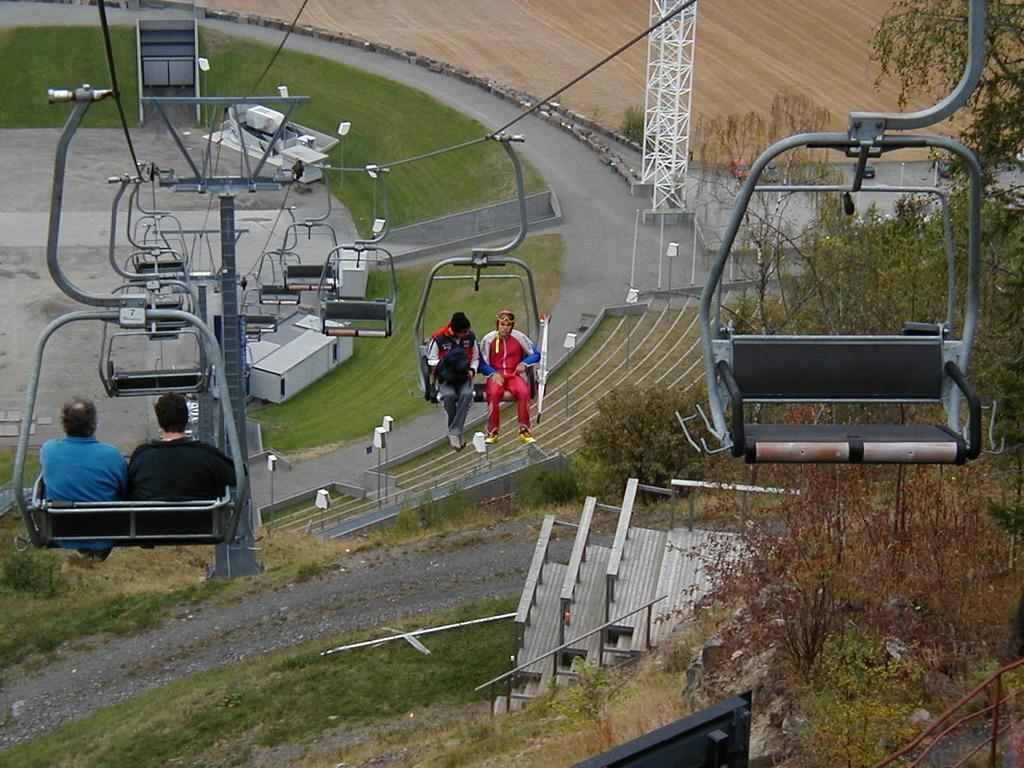What mode of transportation is shown in the image? There are cable cars in the image. Who or what is inside the cable cars? People are sitting in the cable cars. What type of natural scenery can be seen in the image? There are trees visible in the image. What object can be seen in the image that is not a cable car or a person? There is a board in the image. What type of yak is grazing near the cable cars in the image? There are no yaks present in the image; only cable cars, people, trees, and a board can be seen. 